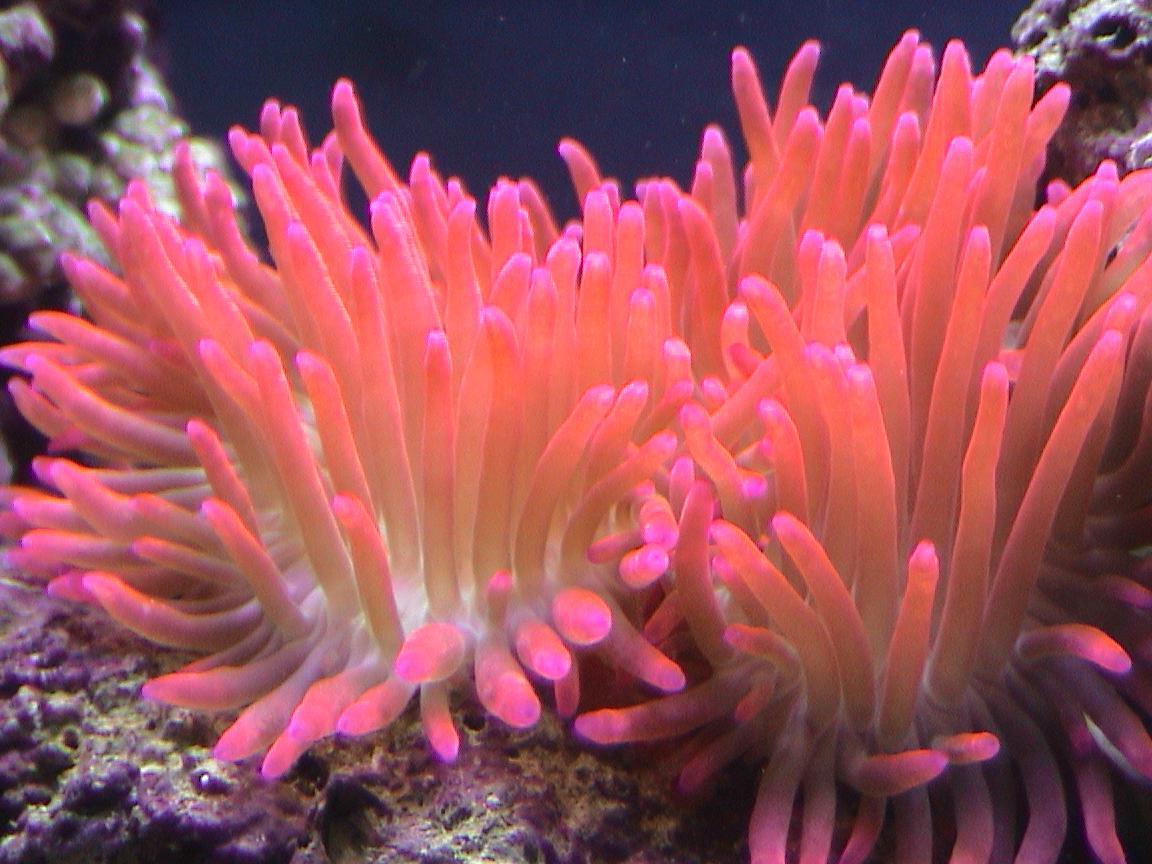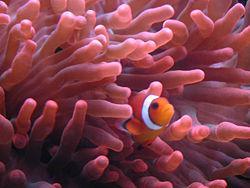The first image is the image on the left, the second image is the image on the right. For the images shown, is this caption "The right image shows a pinkish anemone with a fish in its tendrils." true? Answer yes or no. Yes. The first image is the image on the left, the second image is the image on the right. Given the left and right images, does the statement "In one image, there is a black and white striped fish visible near a sea anemone" hold true? Answer yes or no. No. 